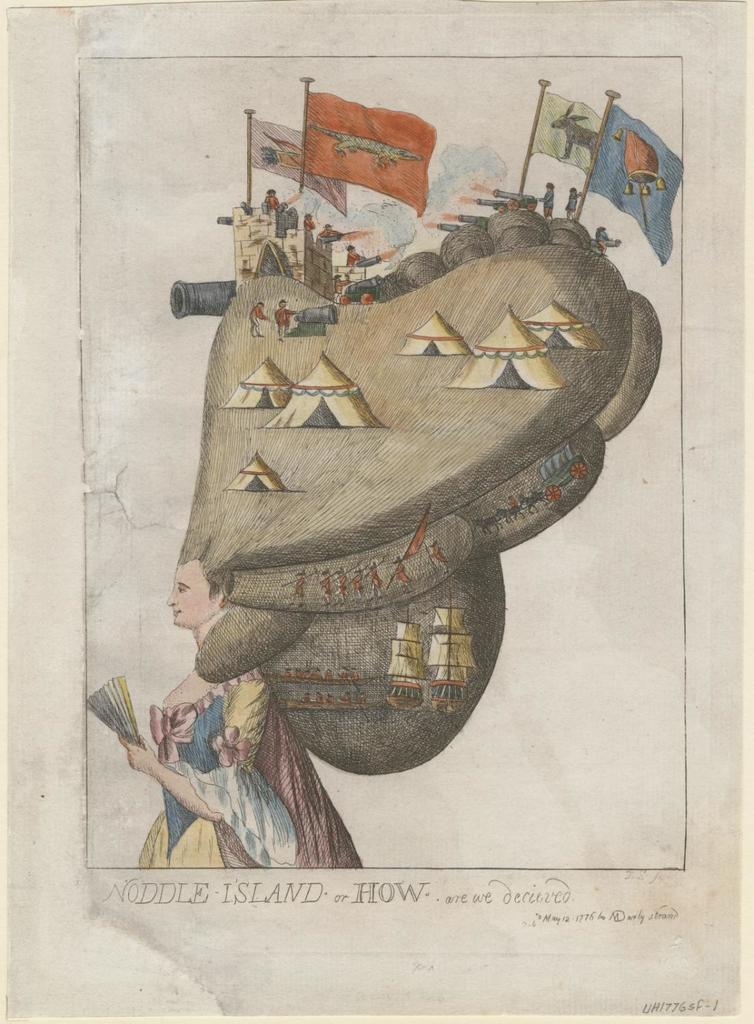What is depicted on the paper in the image? The paper contains a sketch of a woman. What is unique about the woman's appearance in the sketch? The sketch of the woman has tents on her head. Are there any other elements in the sketch besides the woman? Yes, the sketch of the woman has people in it and a flag post. What type of scarf is the woman wearing in the sketch? The sketch does not depict the woman wearing a scarf; it shows tents on her head instead. Can you describe the arch in the sketch? There is no arch present in the sketch; it features a woman with tents on her head, people, and a flag post. 